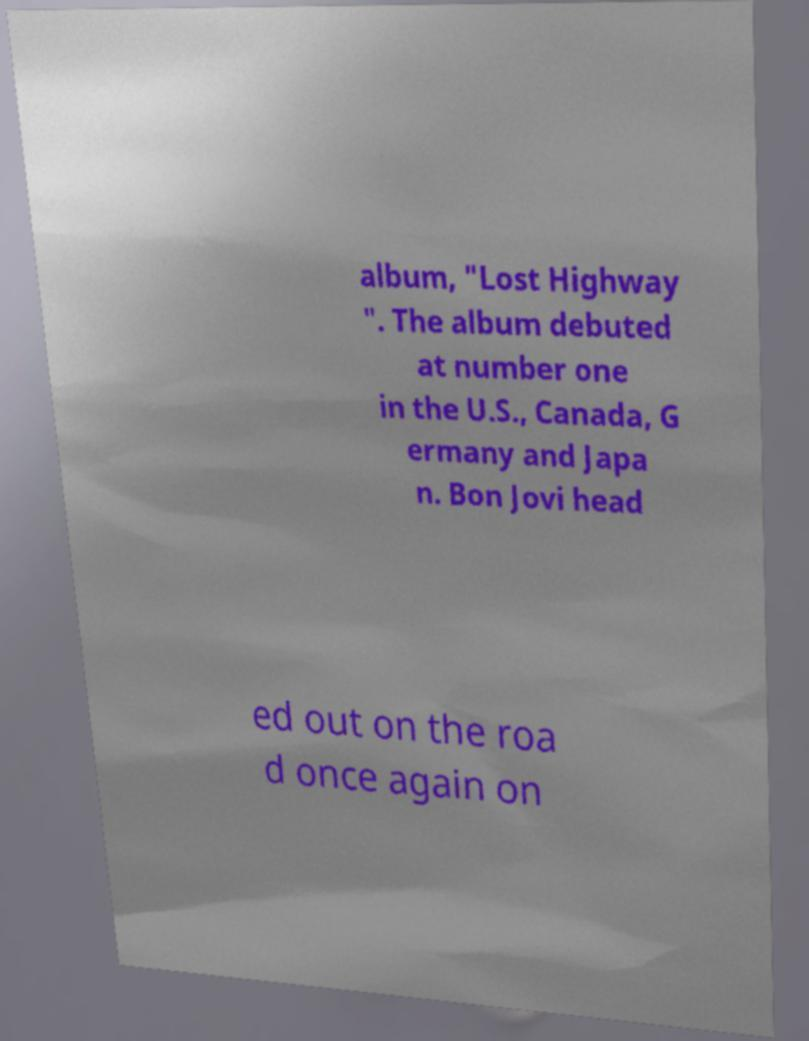Can you accurately transcribe the text from the provided image for me? album, "Lost Highway ". The album debuted at number one in the U.S., Canada, G ermany and Japa n. Bon Jovi head ed out on the roa d once again on 